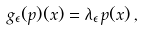Convert formula to latex. <formula><loc_0><loc_0><loc_500><loc_500>g _ { \epsilon } ( p ) ( x ) = \lambda _ { \epsilon } \, p ( x ) \, ,</formula> 